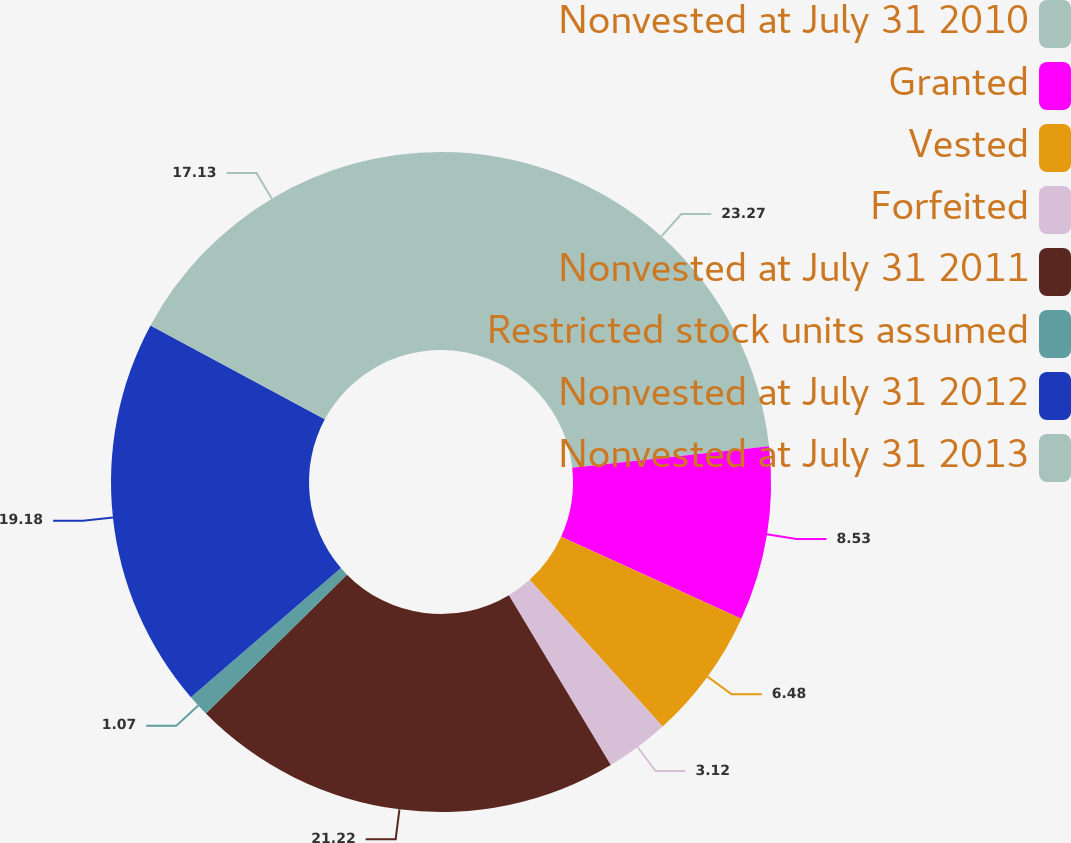Convert chart. <chart><loc_0><loc_0><loc_500><loc_500><pie_chart><fcel>Nonvested at July 31 2010<fcel>Granted<fcel>Vested<fcel>Forfeited<fcel>Nonvested at July 31 2011<fcel>Restricted stock units assumed<fcel>Nonvested at July 31 2012<fcel>Nonvested at July 31 2013<nl><fcel>23.27%<fcel>8.53%<fcel>6.48%<fcel>3.12%<fcel>21.22%<fcel>1.07%<fcel>19.18%<fcel>17.13%<nl></chart> 